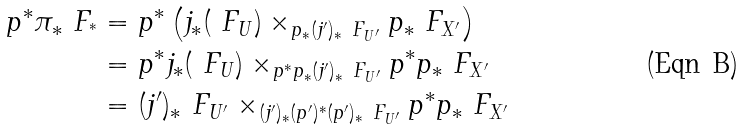Convert formula to latex. <formula><loc_0><loc_0><loc_500><loc_500>p ^ { * } \pi _ { * } \ F _ { ^ { * } } & = p ^ { * } \left ( j _ { * } ( \ F _ { U } ) \times _ { p _ { * } ( j ^ { \prime } ) _ { * } \ F _ { U ^ { \prime } } } p _ { * } \ F _ { X ^ { \prime } } \right ) \\ & = p ^ { * } j _ { * } ( \ F _ { U } ) \times _ { p ^ { * } p _ { * } ( j ^ { \prime } ) _ { * } \ F _ { U ^ { \prime } } } p ^ { * } p _ { * } \ F _ { X ^ { \prime } } \\ & = ( j ^ { \prime } ) _ { * } \ F _ { U ^ { \prime } } \times _ { ( j ^ { \prime } ) _ { * } ( p ^ { \prime } ) ^ { * } ( p ^ { \prime } ) _ { * } \ F _ { U ^ { \prime } } } p ^ { * } p _ { * } \ F _ { X ^ { \prime } }</formula> 